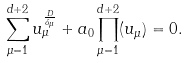Convert formula to latex. <formula><loc_0><loc_0><loc_500><loc_500>\sum _ { \mu = 1 } ^ { d + 2 } u _ { \mu } ^ { \frac { D } { \delta _ { \mu } } } + a _ { 0 } \prod _ { \mu = 1 } ^ { d + 2 } ( u _ { \mu } ) = 0 .</formula> 